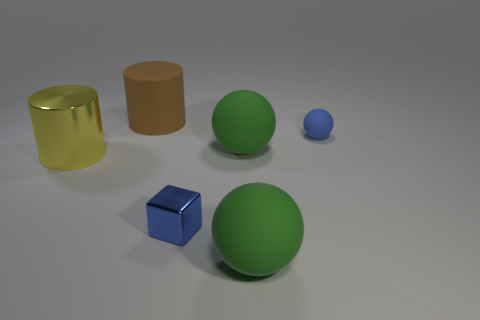Is there a big sphere that has the same material as the brown cylinder? Yes, there is a larger green sphere that appears to have the same matte finish as the brown cylinder, suggesting they could be made from similar materials. 